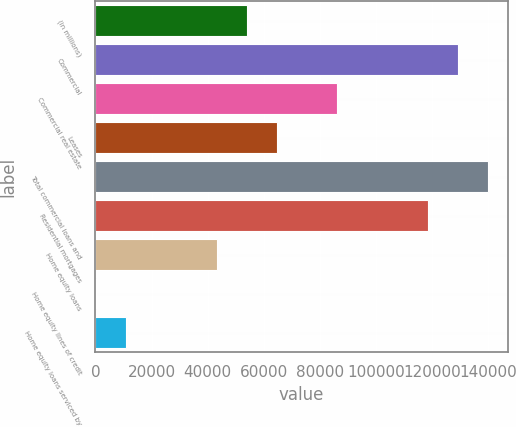Convert chart to OTSL. <chart><loc_0><loc_0><loc_500><loc_500><bar_chart><fcel>(in millions)<fcel>Commercial<fcel>Commercial real estate<fcel>Leases<fcel>Total commercial loans and<fcel>Residential mortgages<fcel>Home equity loans<fcel>Home equity lines of credit<fcel>Home equity loans serviced by<nl><fcel>53944<fcel>129159<fcel>86179<fcel>64689<fcel>139904<fcel>118414<fcel>43199<fcel>219<fcel>10964<nl></chart> 